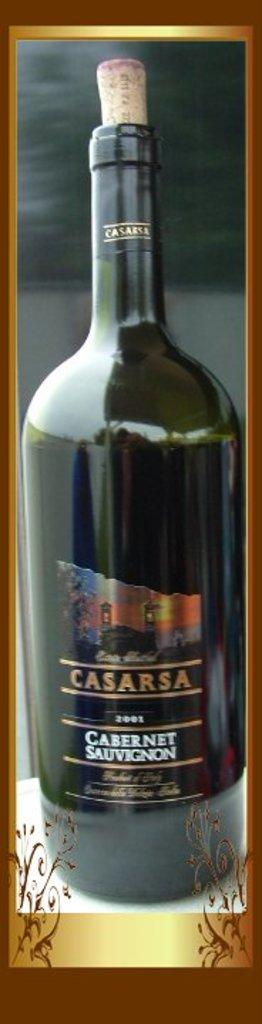What object can be seen in the image? There is a bottle in the image. What is on the bottle? There is a sticker on the bottle. What is written on the sticker? There is text on the sticker. How would you describe the background of the image? The background of the image is blurry. What type of robin is perched on the bottle in the image? There is no robin present in the image; it only features a bottle with a sticker and a blurry background. 